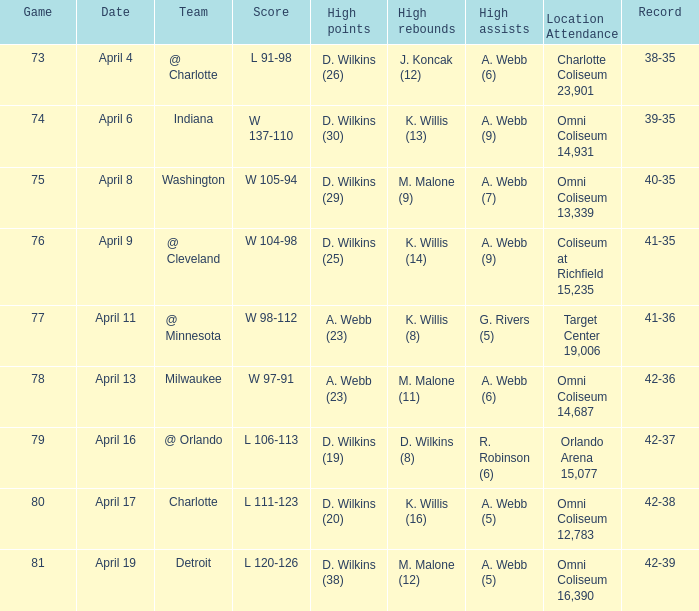When did the game with a 104-98 outcome occur? April 9. 